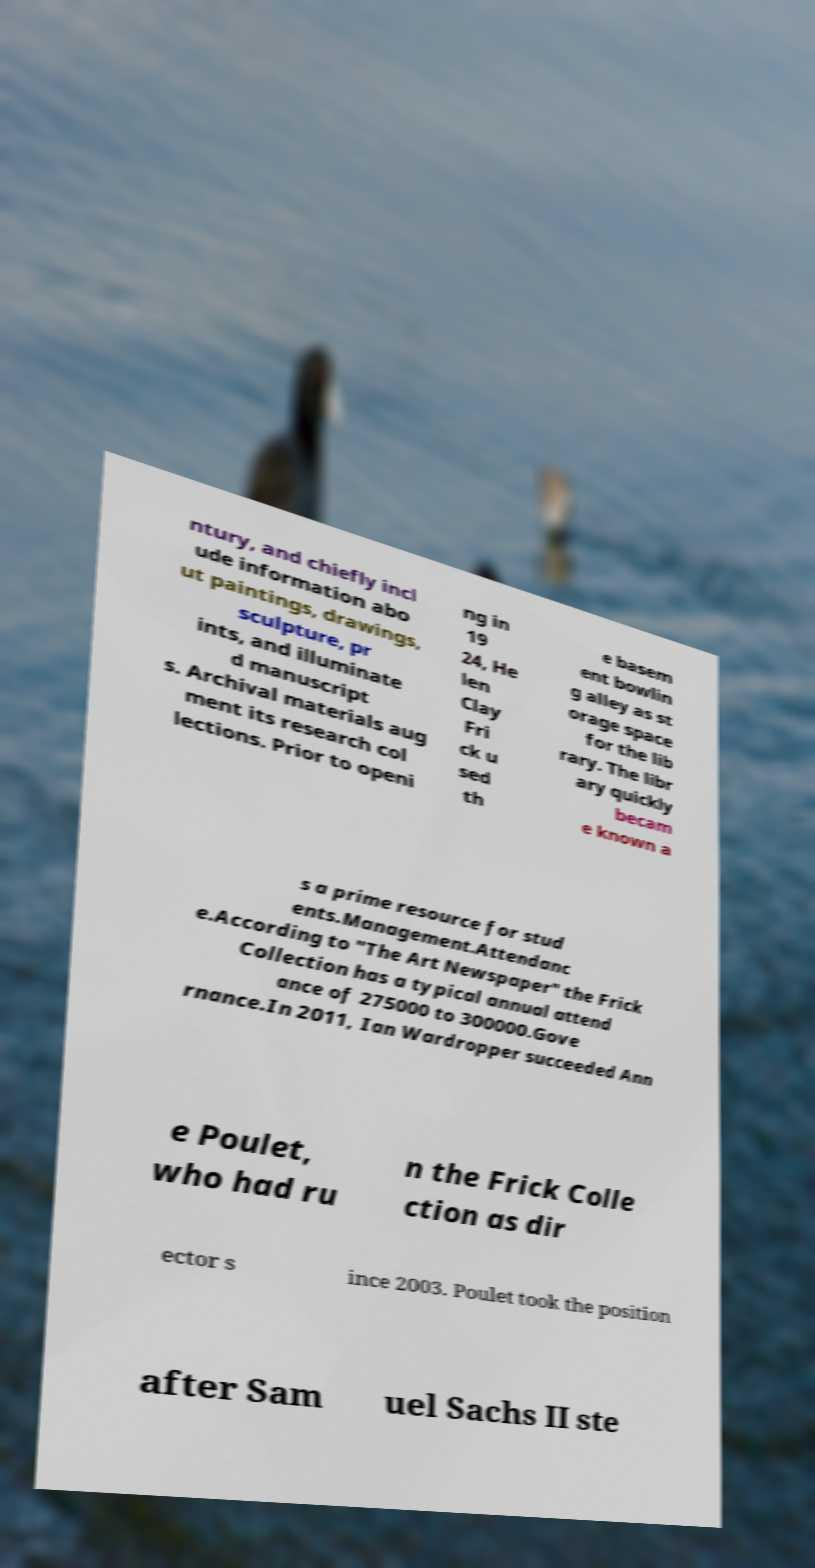Could you assist in decoding the text presented in this image and type it out clearly? ntury, and chiefly incl ude information abo ut paintings, drawings, sculpture, pr ints, and illuminate d manuscript s. Archival materials aug ment its research col lections. Prior to openi ng in 19 24, He len Clay Fri ck u sed th e basem ent bowlin g alley as st orage space for the lib rary. The libr ary quickly becam e known a s a prime resource for stud ents.Management.Attendanc e.According to "The Art Newspaper" the Frick Collection has a typical annual attend ance of 275000 to 300000.Gove rnance.In 2011, Ian Wardropper succeeded Ann e Poulet, who had ru n the Frick Colle ction as dir ector s ince 2003. Poulet took the position after Sam uel Sachs II ste 